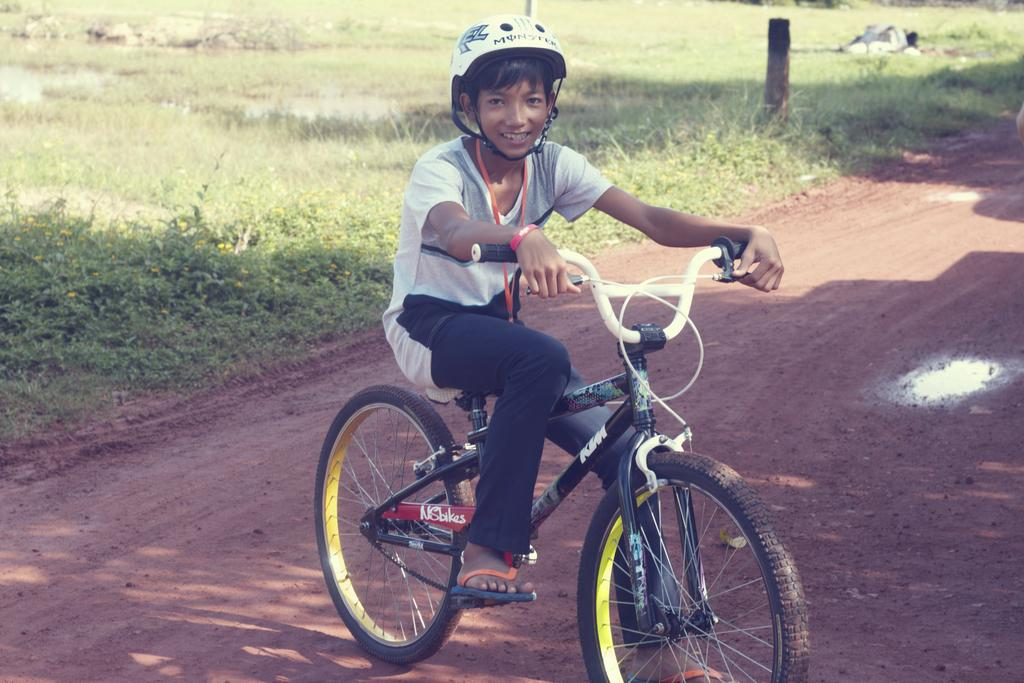What is there is a person in the image, what are they doing? There is a person sitting on a bicycle in the image. How is the person interacting with the bicycle? The person is holding the bicycle handle. What safety precaution is the person taking? The person is wearing a helmet. What can be seen in the background of the image? There is grass and stones visible in the background. What type of hair product is the person using in the image? There is no hair product visible in the image, as the person is wearing a helmet. What offer is the person making to the viewer in the image? There is no offer being made in the image; the person is simply sitting on a bicycle. 